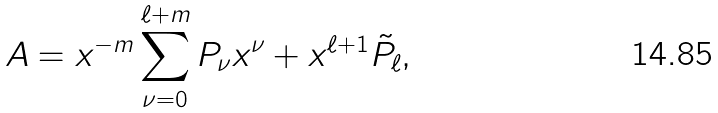Convert formula to latex. <formula><loc_0><loc_0><loc_500><loc_500>A = x ^ { - m } \sum _ { \nu = 0 } ^ { \ell + m } P _ { \nu } x ^ { \nu } + x ^ { \ell + 1 } \tilde { P } _ { \ell } ,</formula> 